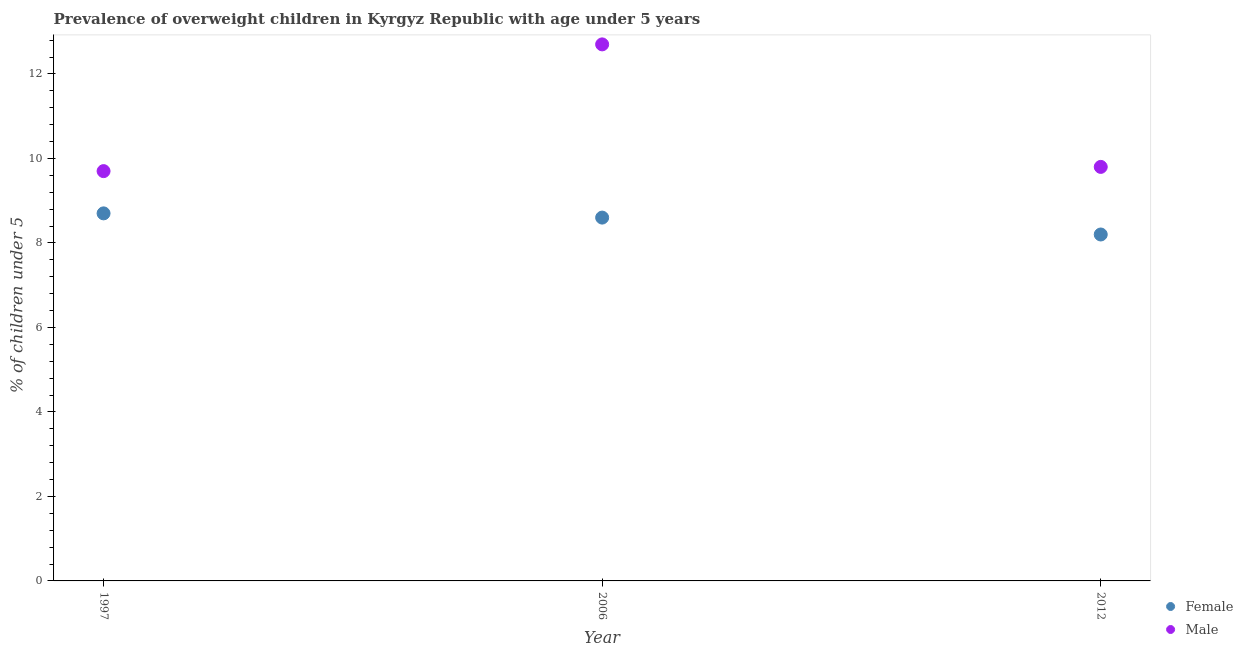How many different coloured dotlines are there?
Your response must be concise. 2. What is the percentage of obese male children in 2006?
Offer a very short reply. 12.7. Across all years, what is the maximum percentage of obese female children?
Provide a short and direct response. 8.7. Across all years, what is the minimum percentage of obese male children?
Your answer should be compact. 9.7. In which year was the percentage of obese male children maximum?
Your response must be concise. 2006. In which year was the percentage of obese female children minimum?
Your answer should be very brief. 2012. What is the total percentage of obese male children in the graph?
Your answer should be very brief. 32.2. What is the difference between the percentage of obese male children in 1997 and that in 2012?
Give a very brief answer. -0.1. What is the difference between the percentage of obese male children in 1997 and the percentage of obese female children in 2012?
Make the answer very short. 1.5. What is the average percentage of obese male children per year?
Your answer should be very brief. 10.73. In the year 2006, what is the difference between the percentage of obese female children and percentage of obese male children?
Offer a terse response. -4.1. What is the ratio of the percentage of obese male children in 2006 to that in 2012?
Keep it short and to the point. 1.3. Is the percentage of obese female children in 1997 less than that in 2012?
Ensure brevity in your answer.  No. Is the difference between the percentage of obese female children in 2006 and 2012 greater than the difference between the percentage of obese male children in 2006 and 2012?
Provide a succinct answer. No. What is the difference between the highest and the second highest percentage of obese female children?
Give a very brief answer. 0.1. What is the difference between the highest and the lowest percentage of obese male children?
Provide a short and direct response. 3. Does the percentage of obese male children monotonically increase over the years?
Offer a terse response. No. Is the percentage of obese male children strictly greater than the percentage of obese female children over the years?
Provide a short and direct response. Yes. Is the percentage of obese female children strictly less than the percentage of obese male children over the years?
Keep it short and to the point. Yes. What is the difference between two consecutive major ticks on the Y-axis?
Your answer should be compact. 2. Are the values on the major ticks of Y-axis written in scientific E-notation?
Give a very brief answer. No. Does the graph contain any zero values?
Provide a short and direct response. No. Where does the legend appear in the graph?
Keep it short and to the point. Bottom right. How many legend labels are there?
Your answer should be compact. 2. What is the title of the graph?
Make the answer very short. Prevalence of overweight children in Kyrgyz Republic with age under 5 years. Does "All education staff compensation" appear as one of the legend labels in the graph?
Make the answer very short. No. What is the label or title of the Y-axis?
Your answer should be very brief.  % of children under 5. What is the  % of children under 5 of Female in 1997?
Offer a very short reply. 8.7. What is the  % of children under 5 of Male in 1997?
Offer a terse response. 9.7. What is the  % of children under 5 in Female in 2006?
Make the answer very short. 8.6. What is the  % of children under 5 in Male in 2006?
Give a very brief answer. 12.7. What is the  % of children under 5 in Female in 2012?
Provide a short and direct response. 8.2. What is the  % of children under 5 in Male in 2012?
Provide a succinct answer. 9.8. Across all years, what is the maximum  % of children under 5 of Female?
Give a very brief answer. 8.7. Across all years, what is the maximum  % of children under 5 in Male?
Provide a short and direct response. 12.7. Across all years, what is the minimum  % of children under 5 of Female?
Offer a very short reply. 8.2. Across all years, what is the minimum  % of children under 5 in Male?
Keep it short and to the point. 9.7. What is the total  % of children under 5 of Male in the graph?
Your answer should be compact. 32.2. What is the difference between the  % of children under 5 in Male in 1997 and that in 2006?
Provide a short and direct response. -3. What is the difference between the  % of children under 5 in Female in 1997 and the  % of children under 5 in Male in 2006?
Provide a short and direct response. -4. What is the difference between the  % of children under 5 in Female in 2006 and the  % of children under 5 in Male in 2012?
Provide a short and direct response. -1.2. What is the average  % of children under 5 of Female per year?
Your answer should be very brief. 8.5. What is the average  % of children under 5 of Male per year?
Give a very brief answer. 10.73. In the year 2012, what is the difference between the  % of children under 5 in Female and  % of children under 5 in Male?
Provide a short and direct response. -1.6. What is the ratio of the  % of children under 5 in Female in 1997 to that in 2006?
Your answer should be very brief. 1.01. What is the ratio of the  % of children under 5 of Male in 1997 to that in 2006?
Give a very brief answer. 0.76. What is the ratio of the  % of children under 5 of Female in 1997 to that in 2012?
Give a very brief answer. 1.06. What is the ratio of the  % of children under 5 in Female in 2006 to that in 2012?
Offer a terse response. 1.05. What is the ratio of the  % of children under 5 in Male in 2006 to that in 2012?
Give a very brief answer. 1.3. What is the difference between the highest and the second highest  % of children under 5 in Male?
Make the answer very short. 2.9. What is the difference between the highest and the lowest  % of children under 5 of Male?
Keep it short and to the point. 3. 